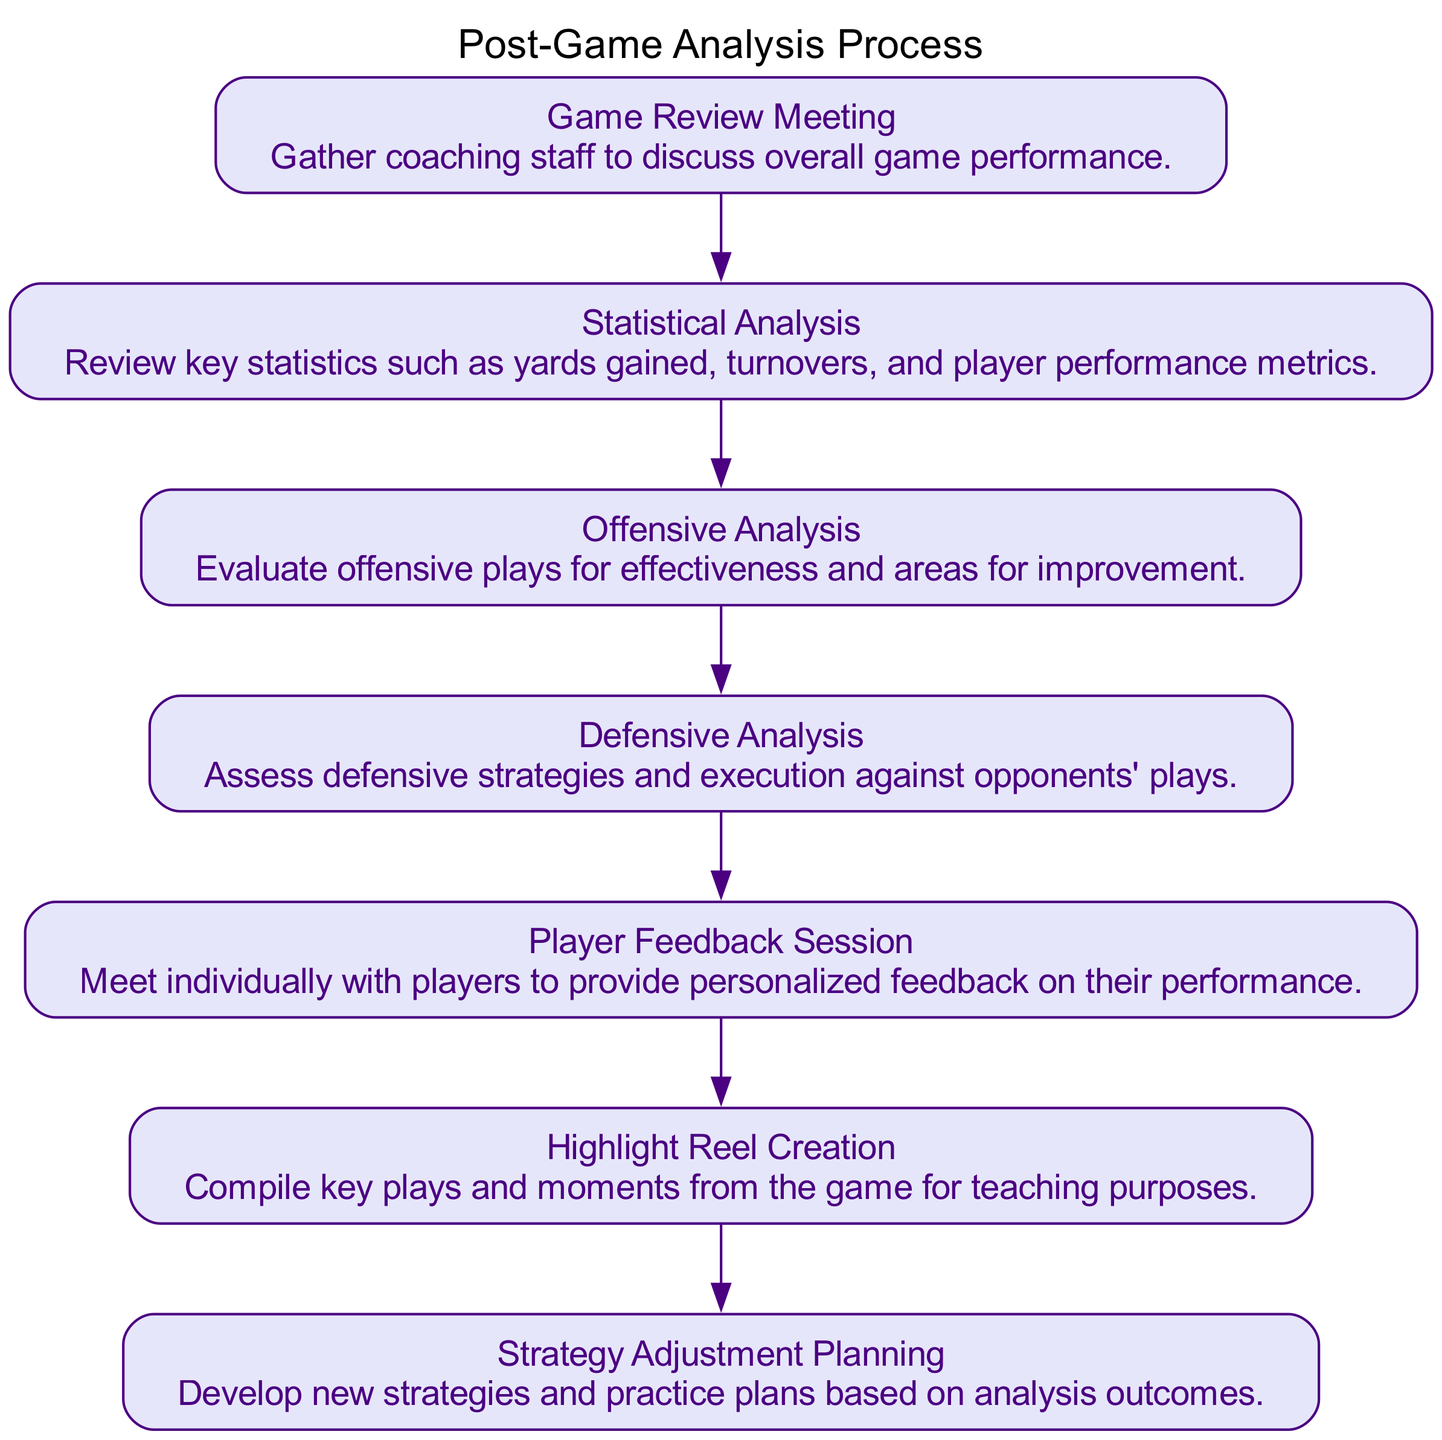What is the first stage of the post-game analysis process? The first stage in the flow chart is "Game Review Meeting". It's the starting point for the analysis where the coaching staff gathers to discuss game performance.
Answer: Game Review Meeting How many stages are there in the post-game analysis process? By counting the number of stages listed in the flow chart, we find there are a total of seven distinct stages.
Answer: Seven What follows the "Defensive Analysis" stage? According to the diagram, the stage that follows "Defensive Analysis" is "Player Feedback Session", indicating the sequence of the process.
Answer: Player Feedback Session What is the purpose of the "Highlight Reel Creation" stage? The flow chart describes this stage as compiling key plays for teaching purposes, which means it serves an educational function after analyzing the game.
Answer: Compile key plays for teaching purposes Which stages focus specifically on player performance? Two stages specifically focus on player performance: "Statistical Analysis" and "Player Feedback Session". This implies both analyzing metrics and providing individualized feedback.
Answer: Statistical Analysis and Player Feedback Session What is the last stage in the post-game analysis process? The last stage is "Strategy Adjustment Planning", which implies that insights from earlier analyses are used to develop new strategies for future games.
Answer: Strategy Adjustment Planning Which stage involves gathering the coaching staff? The stage that involves gathering the coaching staff is "Game Review Meeting", where the staff discusses the overall performance of the game.
Answer: Game Review Meeting How does "Statistical Analysis" relate to "Offensive Analysis"? "Statistical Analysis" is a prerequisite to "Offensive Analysis", suggesting that statistical insights inform evaluations of offensive plays.
Answer: "Statistical Analysis" informs "Offensive Analysis" 